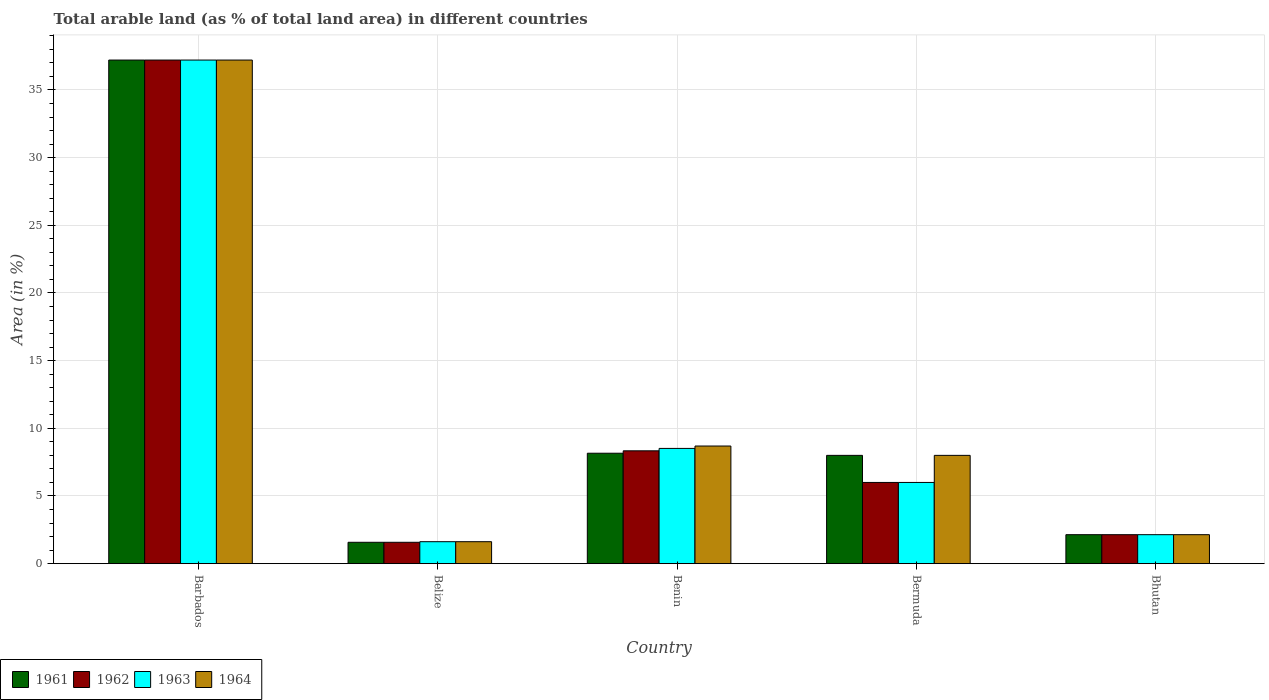Are the number of bars per tick equal to the number of legend labels?
Make the answer very short. Yes. What is the label of the 3rd group of bars from the left?
Give a very brief answer. Benin. What is the percentage of arable land in 1963 in Barbados?
Keep it short and to the point. 37.21. Across all countries, what is the maximum percentage of arable land in 1961?
Your answer should be very brief. 37.21. Across all countries, what is the minimum percentage of arable land in 1964?
Your answer should be compact. 1.62. In which country was the percentage of arable land in 1962 maximum?
Make the answer very short. Barbados. In which country was the percentage of arable land in 1961 minimum?
Offer a very short reply. Belize. What is the total percentage of arable land in 1963 in the graph?
Ensure brevity in your answer.  55.49. What is the difference between the percentage of arable land in 1962 in Belize and that in Benin?
Your answer should be very brief. -6.76. What is the difference between the percentage of arable land in 1963 in Belize and the percentage of arable land in 1964 in Bhutan?
Keep it short and to the point. -0.52. What is the average percentage of arable land in 1964 per country?
Give a very brief answer. 11.53. In how many countries, is the percentage of arable land in 1963 greater than 27 %?
Offer a very short reply. 1. What is the ratio of the percentage of arable land in 1963 in Barbados to that in Benin?
Keep it short and to the point. 4.37. Is the difference between the percentage of arable land in 1964 in Benin and Bhutan greater than the difference between the percentage of arable land in 1961 in Benin and Bhutan?
Ensure brevity in your answer.  Yes. What is the difference between the highest and the second highest percentage of arable land in 1963?
Provide a succinct answer. -28.7. What is the difference between the highest and the lowest percentage of arable land in 1964?
Your response must be concise. 35.59. Is the sum of the percentage of arable land in 1962 in Belize and Bermuda greater than the maximum percentage of arable land in 1964 across all countries?
Your answer should be very brief. No. Is it the case that in every country, the sum of the percentage of arable land in 1962 and percentage of arable land in 1963 is greater than the sum of percentage of arable land in 1961 and percentage of arable land in 1964?
Offer a very short reply. No. What does the 3rd bar from the left in Bermuda represents?
Provide a succinct answer. 1963. What does the 4th bar from the right in Bhutan represents?
Provide a short and direct response. 1961. How many bars are there?
Offer a terse response. 20. What is the difference between two consecutive major ticks on the Y-axis?
Ensure brevity in your answer.  5. How many legend labels are there?
Your answer should be compact. 4. What is the title of the graph?
Ensure brevity in your answer.  Total arable land (as % of total land area) in different countries. What is the label or title of the X-axis?
Provide a short and direct response. Country. What is the label or title of the Y-axis?
Provide a succinct answer. Area (in %). What is the Area (in %) of 1961 in Barbados?
Your answer should be very brief. 37.21. What is the Area (in %) in 1962 in Barbados?
Provide a short and direct response. 37.21. What is the Area (in %) of 1963 in Barbados?
Offer a very short reply. 37.21. What is the Area (in %) in 1964 in Barbados?
Give a very brief answer. 37.21. What is the Area (in %) in 1961 in Belize?
Your response must be concise. 1.58. What is the Area (in %) in 1962 in Belize?
Keep it short and to the point. 1.58. What is the Area (in %) of 1963 in Belize?
Make the answer very short. 1.62. What is the Area (in %) of 1964 in Belize?
Your answer should be very brief. 1.62. What is the Area (in %) in 1961 in Benin?
Your answer should be compact. 8.16. What is the Area (in %) in 1962 in Benin?
Your answer should be compact. 8.34. What is the Area (in %) in 1963 in Benin?
Offer a terse response. 8.51. What is the Area (in %) in 1964 in Benin?
Offer a very short reply. 8.69. What is the Area (in %) in 1963 in Bermuda?
Provide a short and direct response. 6. What is the Area (in %) in 1961 in Bhutan?
Keep it short and to the point. 2.14. What is the Area (in %) in 1962 in Bhutan?
Ensure brevity in your answer.  2.14. What is the Area (in %) in 1963 in Bhutan?
Your answer should be very brief. 2.14. What is the Area (in %) in 1964 in Bhutan?
Your response must be concise. 2.14. Across all countries, what is the maximum Area (in %) in 1961?
Offer a terse response. 37.21. Across all countries, what is the maximum Area (in %) in 1962?
Make the answer very short. 37.21. Across all countries, what is the maximum Area (in %) of 1963?
Give a very brief answer. 37.21. Across all countries, what is the maximum Area (in %) in 1964?
Keep it short and to the point. 37.21. Across all countries, what is the minimum Area (in %) of 1961?
Provide a short and direct response. 1.58. Across all countries, what is the minimum Area (in %) of 1962?
Ensure brevity in your answer.  1.58. Across all countries, what is the minimum Area (in %) of 1963?
Provide a succinct answer. 1.62. Across all countries, what is the minimum Area (in %) in 1964?
Provide a short and direct response. 1.62. What is the total Area (in %) of 1961 in the graph?
Offer a terse response. 57.09. What is the total Area (in %) of 1962 in the graph?
Offer a very short reply. 55.26. What is the total Area (in %) in 1963 in the graph?
Provide a succinct answer. 55.49. What is the total Area (in %) of 1964 in the graph?
Offer a terse response. 57.66. What is the difference between the Area (in %) in 1961 in Barbados and that in Belize?
Your answer should be compact. 35.63. What is the difference between the Area (in %) in 1962 in Barbados and that in Belize?
Your answer should be very brief. 35.63. What is the difference between the Area (in %) of 1963 in Barbados and that in Belize?
Your answer should be compact. 35.59. What is the difference between the Area (in %) in 1964 in Barbados and that in Belize?
Your answer should be compact. 35.59. What is the difference between the Area (in %) in 1961 in Barbados and that in Benin?
Provide a succinct answer. 29.05. What is the difference between the Area (in %) in 1962 in Barbados and that in Benin?
Your response must be concise. 28.87. What is the difference between the Area (in %) in 1963 in Barbados and that in Benin?
Your answer should be compact. 28.7. What is the difference between the Area (in %) in 1964 in Barbados and that in Benin?
Provide a succinct answer. 28.52. What is the difference between the Area (in %) in 1961 in Barbados and that in Bermuda?
Provide a short and direct response. 29.21. What is the difference between the Area (in %) of 1962 in Barbados and that in Bermuda?
Your answer should be compact. 31.21. What is the difference between the Area (in %) in 1963 in Barbados and that in Bermuda?
Provide a short and direct response. 31.21. What is the difference between the Area (in %) in 1964 in Barbados and that in Bermuda?
Offer a terse response. 29.21. What is the difference between the Area (in %) in 1961 in Barbados and that in Bhutan?
Give a very brief answer. 35.07. What is the difference between the Area (in %) in 1962 in Barbados and that in Bhutan?
Give a very brief answer. 35.07. What is the difference between the Area (in %) of 1963 in Barbados and that in Bhutan?
Provide a succinct answer. 35.07. What is the difference between the Area (in %) in 1964 in Barbados and that in Bhutan?
Keep it short and to the point. 35.07. What is the difference between the Area (in %) of 1961 in Belize and that in Benin?
Make the answer very short. -6.58. What is the difference between the Area (in %) in 1962 in Belize and that in Benin?
Offer a terse response. -6.76. What is the difference between the Area (in %) in 1963 in Belize and that in Benin?
Provide a succinct answer. -6.89. What is the difference between the Area (in %) in 1964 in Belize and that in Benin?
Your answer should be very brief. -7.07. What is the difference between the Area (in %) in 1961 in Belize and that in Bermuda?
Your answer should be very brief. -6.42. What is the difference between the Area (in %) in 1962 in Belize and that in Bermuda?
Offer a very short reply. -4.42. What is the difference between the Area (in %) in 1963 in Belize and that in Bermuda?
Offer a terse response. -4.38. What is the difference between the Area (in %) in 1964 in Belize and that in Bermuda?
Ensure brevity in your answer.  -6.38. What is the difference between the Area (in %) in 1961 in Belize and that in Bhutan?
Your answer should be very brief. -0.56. What is the difference between the Area (in %) of 1962 in Belize and that in Bhutan?
Give a very brief answer. -0.56. What is the difference between the Area (in %) of 1963 in Belize and that in Bhutan?
Give a very brief answer. -0.52. What is the difference between the Area (in %) of 1964 in Belize and that in Bhutan?
Make the answer very short. -0.52. What is the difference between the Area (in %) in 1961 in Benin and that in Bermuda?
Ensure brevity in your answer.  0.16. What is the difference between the Area (in %) in 1962 in Benin and that in Bermuda?
Make the answer very short. 2.34. What is the difference between the Area (in %) of 1963 in Benin and that in Bermuda?
Ensure brevity in your answer.  2.51. What is the difference between the Area (in %) of 1964 in Benin and that in Bermuda?
Your response must be concise. 0.69. What is the difference between the Area (in %) of 1961 in Benin and that in Bhutan?
Your response must be concise. 6.02. What is the difference between the Area (in %) in 1962 in Benin and that in Bhutan?
Offer a terse response. 6.2. What is the difference between the Area (in %) in 1963 in Benin and that in Bhutan?
Offer a very short reply. 6.37. What is the difference between the Area (in %) of 1964 in Benin and that in Bhutan?
Offer a terse response. 6.55. What is the difference between the Area (in %) in 1961 in Bermuda and that in Bhutan?
Make the answer very short. 5.86. What is the difference between the Area (in %) of 1962 in Bermuda and that in Bhutan?
Your response must be concise. 3.86. What is the difference between the Area (in %) of 1963 in Bermuda and that in Bhutan?
Your answer should be compact. 3.86. What is the difference between the Area (in %) of 1964 in Bermuda and that in Bhutan?
Your answer should be very brief. 5.86. What is the difference between the Area (in %) in 1961 in Barbados and the Area (in %) in 1962 in Belize?
Offer a terse response. 35.63. What is the difference between the Area (in %) of 1961 in Barbados and the Area (in %) of 1963 in Belize?
Provide a succinct answer. 35.59. What is the difference between the Area (in %) in 1961 in Barbados and the Area (in %) in 1964 in Belize?
Your answer should be compact. 35.59. What is the difference between the Area (in %) in 1962 in Barbados and the Area (in %) in 1963 in Belize?
Make the answer very short. 35.59. What is the difference between the Area (in %) of 1962 in Barbados and the Area (in %) of 1964 in Belize?
Your response must be concise. 35.59. What is the difference between the Area (in %) of 1963 in Barbados and the Area (in %) of 1964 in Belize?
Offer a very short reply. 35.59. What is the difference between the Area (in %) in 1961 in Barbados and the Area (in %) in 1962 in Benin?
Give a very brief answer. 28.87. What is the difference between the Area (in %) in 1961 in Barbados and the Area (in %) in 1963 in Benin?
Make the answer very short. 28.7. What is the difference between the Area (in %) in 1961 in Barbados and the Area (in %) in 1964 in Benin?
Give a very brief answer. 28.52. What is the difference between the Area (in %) in 1962 in Barbados and the Area (in %) in 1963 in Benin?
Your answer should be compact. 28.7. What is the difference between the Area (in %) in 1962 in Barbados and the Area (in %) in 1964 in Benin?
Provide a succinct answer. 28.52. What is the difference between the Area (in %) of 1963 in Barbados and the Area (in %) of 1964 in Benin?
Offer a terse response. 28.52. What is the difference between the Area (in %) of 1961 in Barbados and the Area (in %) of 1962 in Bermuda?
Provide a succinct answer. 31.21. What is the difference between the Area (in %) in 1961 in Barbados and the Area (in %) in 1963 in Bermuda?
Your answer should be compact. 31.21. What is the difference between the Area (in %) of 1961 in Barbados and the Area (in %) of 1964 in Bermuda?
Provide a succinct answer. 29.21. What is the difference between the Area (in %) of 1962 in Barbados and the Area (in %) of 1963 in Bermuda?
Keep it short and to the point. 31.21. What is the difference between the Area (in %) of 1962 in Barbados and the Area (in %) of 1964 in Bermuda?
Make the answer very short. 29.21. What is the difference between the Area (in %) in 1963 in Barbados and the Area (in %) in 1964 in Bermuda?
Your response must be concise. 29.21. What is the difference between the Area (in %) in 1961 in Barbados and the Area (in %) in 1962 in Bhutan?
Your answer should be compact. 35.07. What is the difference between the Area (in %) of 1961 in Barbados and the Area (in %) of 1963 in Bhutan?
Keep it short and to the point. 35.07. What is the difference between the Area (in %) in 1961 in Barbados and the Area (in %) in 1964 in Bhutan?
Ensure brevity in your answer.  35.07. What is the difference between the Area (in %) of 1962 in Barbados and the Area (in %) of 1963 in Bhutan?
Your answer should be compact. 35.07. What is the difference between the Area (in %) in 1962 in Barbados and the Area (in %) in 1964 in Bhutan?
Your response must be concise. 35.07. What is the difference between the Area (in %) in 1963 in Barbados and the Area (in %) in 1964 in Bhutan?
Your answer should be compact. 35.07. What is the difference between the Area (in %) in 1961 in Belize and the Area (in %) in 1962 in Benin?
Offer a very short reply. -6.76. What is the difference between the Area (in %) of 1961 in Belize and the Area (in %) of 1963 in Benin?
Your answer should be compact. -6.94. What is the difference between the Area (in %) of 1961 in Belize and the Area (in %) of 1964 in Benin?
Ensure brevity in your answer.  -7.11. What is the difference between the Area (in %) of 1962 in Belize and the Area (in %) of 1963 in Benin?
Provide a succinct answer. -6.94. What is the difference between the Area (in %) of 1962 in Belize and the Area (in %) of 1964 in Benin?
Your answer should be very brief. -7.11. What is the difference between the Area (in %) in 1963 in Belize and the Area (in %) in 1964 in Benin?
Your answer should be compact. -7.07. What is the difference between the Area (in %) of 1961 in Belize and the Area (in %) of 1962 in Bermuda?
Your response must be concise. -4.42. What is the difference between the Area (in %) in 1961 in Belize and the Area (in %) in 1963 in Bermuda?
Provide a succinct answer. -4.42. What is the difference between the Area (in %) of 1961 in Belize and the Area (in %) of 1964 in Bermuda?
Ensure brevity in your answer.  -6.42. What is the difference between the Area (in %) in 1962 in Belize and the Area (in %) in 1963 in Bermuda?
Make the answer very short. -4.42. What is the difference between the Area (in %) in 1962 in Belize and the Area (in %) in 1964 in Bermuda?
Your answer should be compact. -6.42. What is the difference between the Area (in %) in 1963 in Belize and the Area (in %) in 1964 in Bermuda?
Offer a very short reply. -6.38. What is the difference between the Area (in %) in 1961 in Belize and the Area (in %) in 1962 in Bhutan?
Offer a very short reply. -0.56. What is the difference between the Area (in %) in 1961 in Belize and the Area (in %) in 1963 in Bhutan?
Ensure brevity in your answer.  -0.56. What is the difference between the Area (in %) of 1961 in Belize and the Area (in %) of 1964 in Bhutan?
Your answer should be very brief. -0.56. What is the difference between the Area (in %) in 1962 in Belize and the Area (in %) in 1963 in Bhutan?
Make the answer very short. -0.56. What is the difference between the Area (in %) in 1962 in Belize and the Area (in %) in 1964 in Bhutan?
Your response must be concise. -0.56. What is the difference between the Area (in %) in 1963 in Belize and the Area (in %) in 1964 in Bhutan?
Offer a terse response. -0.52. What is the difference between the Area (in %) of 1961 in Benin and the Area (in %) of 1962 in Bermuda?
Offer a terse response. 2.16. What is the difference between the Area (in %) in 1961 in Benin and the Area (in %) in 1963 in Bermuda?
Provide a short and direct response. 2.16. What is the difference between the Area (in %) in 1961 in Benin and the Area (in %) in 1964 in Bermuda?
Provide a succinct answer. 0.16. What is the difference between the Area (in %) in 1962 in Benin and the Area (in %) in 1963 in Bermuda?
Make the answer very short. 2.34. What is the difference between the Area (in %) in 1962 in Benin and the Area (in %) in 1964 in Bermuda?
Make the answer very short. 0.34. What is the difference between the Area (in %) of 1963 in Benin and the Area (in %) of 1964 in Bermuda?
Offer a terse response. 0.51. What is the difference between the Area (in %) in 1961 in Benin and the Area (in %) in 1962 in Bhutan?
Offer a very short reply. 6.02. What is the difference between the Area (in %) in 1961 in Benin and the Area (in %) in 1963 in Bhutan?
Give a very brief answer. 6.02. What is the difference between the Area (in %) of 1961 in Benin and the Area (in %) of 1964 in Bhutan?
Offer a terse response. 6.02. What is the difference between the Area (in %) in 1962 in Benin and the Area (in %) in 1963 in Bhutan?
Provide a succinct answer. 6.2. What is the difference between the Area (in %) of 1962 in Benin and the Area (in %) of 1964 in Bhutan?
Give a very brief answer. 6.2. What is the difference between the Area (in %) in 1963 in Benin and the Area (in %) in 1964 in Bhutan?
Offer a very short reply. 6.37. What is the difference between the Area (in %) in 1961 in Bermuda and the Area (in %) in 1962 in Bhutan?
Your answer should be very brief. 5.86. What is the difference between the Area (in %) in 1961 in Bermuda and the Area (in %) in 1963 in Bhutan?
Offer a very short reply. 5.86. What is the difference between the Area (in %) of 1961 in Bermuda and the Area (in %) of 1964 in Bhutan?
Offer a very short reply. 5.86. What is the difference between the Area (in %) of 1962 in Bermuda and the Area (in %) of 1963 in Bhutan?
Provide a short and direct response. 3.86. What is the difference between the Area (in %) in 1962 in Bermuda and the Area (in %) in 1964 in Bhutan?
Provide a short and direct response. 3.86. What is the difference between the Area (in %) in 1963 in Bermuda and the Area (in %) in 1964 in Bhutan?
Offer a very short reply. 3.86. What is the average Area (in %) of 1961 per country?
Offer a very short reply. 11.42. What is the average Area (in %) of 1962 per country?
Provide a short and direct response. 11.05. What is the average Area (in %) in 1963 per country?
Offer a very short reply. 11.1. What is the average Area (in %) in 1964 per country?
Keep it short and to the point. 11.53. What is the difference between the Area (in %) in 1961 and Area (in %) in 1963 in Barbados?
Provide a short and direct response. 0. What is the difference between the Area (in %) of 1961 and Area (in %) of 1964 in Barbados?
Make the answer very short. 0. What is the difference between the Area (in %) in 1962 and Area (in %) in 1963 in Barbados?
Provide a short and direct response. 0. What is the difference between the Area (in %) of 1963 and Area (in %) of 1964 in Barbados?
Provide a short and direct response. 0. What is the difference between the Area (in %) of 1961 and Area (in %) of 1963 in Belize?
Your answer should be compact. -0.04. What is the difference between the Area (in %) in 1961 and Area (in %) in 1964 in Belize?
Your answer should be very brief. -0.04. What is the difference between the Area (in %) of 1962 and Area (in %) of 1963 in Belize?
Provide a short and direct response. -0.04. What is the difference between the Area (in %) of 1962 and Area (in %) of 1964 in Belize?
Give a very brief answer. -0.04. What is the difference between the Area (in %) in 1961 and Area (in %) in 1962 in Benin?
Give a very brief answer. -0.18. What is the difference between the Area (in %) of 1961 and Area (in %) of 1963 in Benin?
Provide a succinct answer. -0.35. What is the difference between the Area (in %) in 1961 and Area (in %) in 1964 in Benin?
Ensure brevity in your answer.  -0.53. What is the difference between the Area (in %) of 1962 and Area (in %) of 1963 in Benin?
Provide a succinct answer. -0.18. What is the difference between the Area (in %) of 1962 and Area (in %) of 1964 in Benin?
Provide a succinct answer. -0.35. What is the difference between the Area (in %) in 1963 and Area (in %) in 1964 in Benin?
Provide a succinct answer. -0.18. What is the difference between the Area (in %) of 1961 and Area (in %) of 1962 in Bermuda?
Your response must be concise. 2. What is the difference between the Area (in %) of 1961 and Area (in %) of 1964 in Bermuda?
Keep it short and to the point. 0. What is the difference between the Area (in %) of 1962 and Area (in %) of 1963 in Bermuda?
Your answer should be very brief. 0. What is the difference between the Area (in %) in 1961 and Area (in %) in 1962 in Bhutan?
Provide a succinct answer. 0. What is the difference between the Area (in %) in 1963 and Area (in %) in 1964 in Bhutan?
Offer a very short reply. 0. What is the ratio of the Area (in %) in 1961 in Barbados to that in Belize?
Make the answer very short. 23.58. What is the ratio of the Area (in %) in 1962 in Barbados to that in Belize?
Offer a terse response. 23.58. What is the ratio of the Area (in %) of 1963 in Barbados to that in Belize?
Provide a succinct answer. 22.94. What is the ratio of the Area (in %) of 1964 in Barbados to that in Belize?
Give a very brief answer. 22.94. What is the ratio of the Area (in %) of 1961 in Barbados to that in Benin?
Give a very brief answer. 4.56. What is the ratio of the Area (in %) of 1962 in Barbados to that in Benin?
Provide a succinct answer. 4.46. What is the ratio of the Area (in %) in 1963 in Barbados to that in Benin?
Offer a terse response. 4.37. What is the ratio of the Area (in %) of 1964 in Barbados to that in Benin?
Your response must be concise. 4.28. What is the ratio of the Area (in %) of 1961 in Barbados to that in Bermuda?
Offer a terse response. 4.65. What is the ratio of the Area (in %) of 1962 in Barbados to that in Bermuda?
Make the answer very short. 6.2. What is the ratio of the Area (in %) in 1963 in Barbados to that in Bermuda?
Keep it short and to the point. 6.2. What is the ratio of the Area (in %) in 1964 in Barbados to that in Bermuda?
Offer a terse response. 4.65. What is the ratio of the Area (in %) of 1961 in Barbados to that in Bhutan?
Give a very brief answer. 17.39. What is the ratio of the Area (in %) in 1962 in Barbados to that in Bhutan?
Provide a succinct answer. 17.39. What is the ratio of the Area (in %) of 1963 in Barbados to that in Bhutan?
Keep it short and to the point. 17.39. What is the ratio of the Area (in %) of 1964 in Barbados to that in Bhutan?
Give a very brief answer. 17.39. What is the ratio of the Area (in %) of 1961 in Belize to that in Benin?
Provide a succinct answer. 0.19. What is the ratio of the Area (in %) of 1962 in Belize to that in Benin?
Offer a very short reply. 0.19. What is the ratio of the Area (in %) in 1963 in Belize to that in Benin?
Your answer should be very brief. 0.19. What is the ratio of the Area (in %) in 1964 in Belize to that in Benin?
Provide a short and direct response. 0.19. What is the ratio of the Area (in %) in 1961 in Belize to that in Bermuda?
Give a very brief answer. 0.2. What is the ratio of the Area (in %) of 1962 in Belize to that in Bermuda?
Provide a short and direct response. 0.26. What is the ratio of the Area (in %) in 1963 in Belize to that in Bermuda?
Your answer should be compact. 0.27. What is the ratio of the Area (in %) in 1964 in Belize to that in Bermuda?
Ensure brevity in your answer.  0.2. What is the ratio of the Area (in %) in 1961 in Belize to that in Bhutan?
Offer a terse response. 0.74. What is the ratio of the Area (in %) in 1962 in Belize to that in Bhutan?
Make the answer very short. 0.74. What is the ratio of the Area (in %) in 1963 in Belize to that in Bhutan?
Your answer should be very brief. 0.76. What is the ratio of the Area (in %) in 1964 in Belize to that in Bhutan?
Give a very brief answer. 0.76. What is the ratio of the Area (in %) in 1961 in Benin to that in Bermuda?
Your response must be concise. 1.02. What is the ratio of the Area (in %) of 1962 in Benin to that in Bermuda?
Provide a short and direct response. 1.39. What is the ratio of the Area (in %) in 1963 in Benin to that in Bermuda?
Keep it short and to the point. 1.42. What is the ratio of the Area (in %) of 1964 in Benin to that in Bermuda?
Offer a terse response. 1.09. What is the ratio of the Area (in %) in 1961 in Benin to that in Bhutan?
Offer a terse response. 3.81. What is the ratio of the Area (in %) of 1962 in Benin to that in Bhutan?
Make the answer very short. 3.9. What is the ratio of the Area (in %) in 1963 in Benin to that in Bhutan?
Ensure brevity in your answer.  3.98. What is the ratio of the Area (in %) of 1964 in Benin to that in Bhutan?
Your answer should be compact. 4.06. What is the ratio of the Area (in %) in 1961 in Bermuda to that in Bhutan?
Provide a short and direct response. 3.74. What is the ratio of the Area (in %) of 1962 in Bermuda to that in Bhutan?
Your answer should be compact. 2.8. What is the ratio of the Area (in %) of 1963 in Bermuda to that in Bhutan?
Your answer should be compact. 2.8. What is the ratio of the Area (in %) of 1964 in Bermuda to that in Bhutan?
Your response must be concise. 3.74. What is the difference between the highest and the second highest Area (in %) in 1961?
Ensure brevity in your answer.  29.05. What is the difference between the highest and the second highest Area (in %) of 1962?
Provide a short and direct response. 28.87. What is the difference between the highest and the second highest Area (in %) in 1963?
Ensure brevity in your answer.  28.7. What is the difference between the highest and the second highest Area (in %) of 1964?
Provide a succinct answer. 28.52. What is the difference between the highest and the lowest Area (in %) of 1961?
Ensure brevity in your answer.  35.63. What is the difference between the highest and the lowest Area (in %) in 1962?
Provide a short and direct response. 35.63. What is the difference between the highest and the lowest Area (in %) of 1963?
Provide a short and direct response. 35.59. What is the difference between the highest and the lowest Area (in %) of 1964?
Your answer should be very brief. 35.59. 